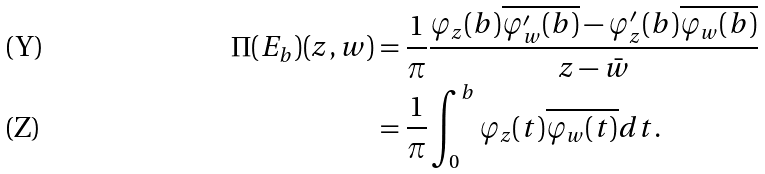Convert formula to latex. <formula><loc_0><loc_0><loc_500><loc_500>\Pi ( E _ { b } ) ( z , w ) & = \frac { 1 } { \pi } \frac { \varphi _ { z } ( b ) \overline { \varphi ^ { \prime } _ { w } ( b ) } - \varphi ^ { \prime } _ { z } ( b ) \overline { \varphi _ { w } ( b ) } } { z - \bar { w } } \\ & = \frac { 1 } { \pi } \int _ { 0 } ^ { b } \varphi _ { z } ( t ) \overline { \varphi _ { w } ( t ) } d t .</formula> 